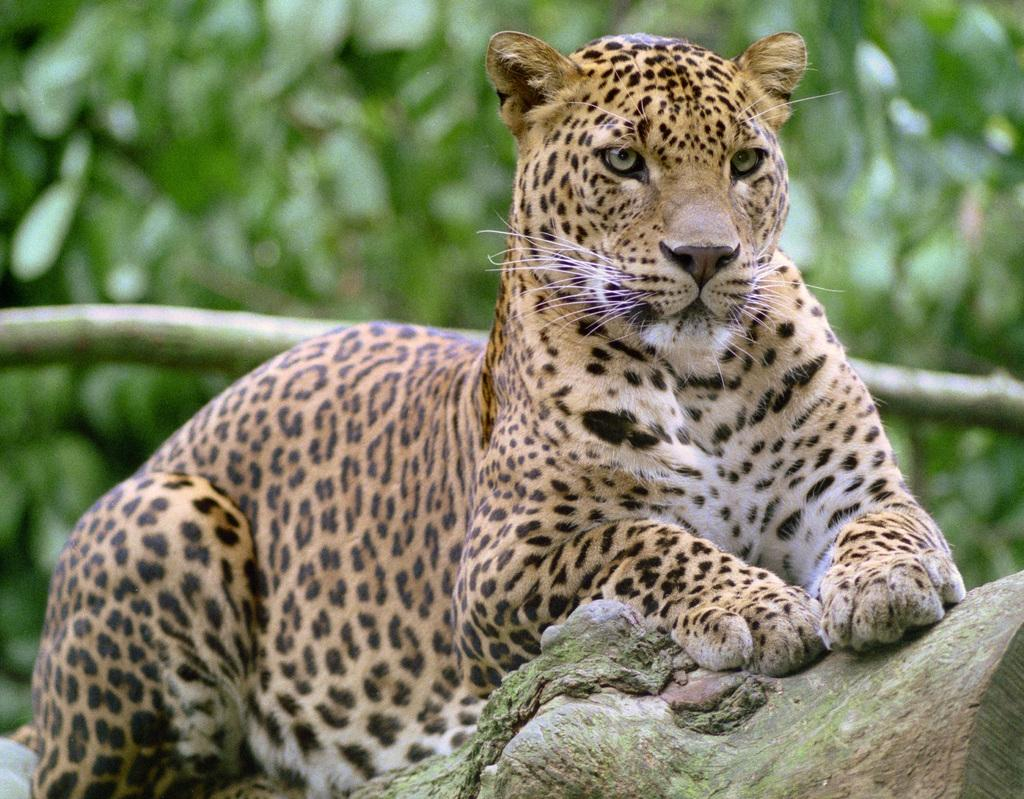What animal is the main subject of the image? There is a cheetah in the image. What is the cheetah doing in the image? The cheetah is sitting on a trunk. What can be seen in the background of the image? There are trees in the background of the image. Where is the ladybug in the image? There is no ladybug present in the image. What type of whip is being used by the cheetah in the image? There is no whip present in the image, and the cheetah is not using any tool or object. 